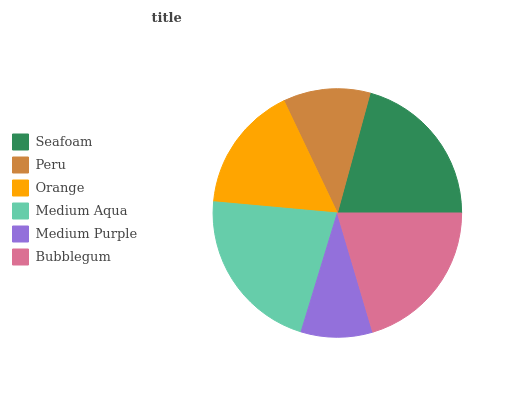Is Medium Purple the minimum?
Answer yes or no. Yes. Is Medium Aqua the maximum?
Answer yes or no. Yes. Is Peru the minimum?
Answer yes or no. No. Is Peru the maximum?
Answer yes or no. No. Is Seafoam greater than Peru?
Answer yes or no. Yes. Is Peru less than Seafoam?
Answer yes or no. Yes. Is Peru greater than Seafoam?
Answer yes or no. No. Is Seafoam less than Peru?
Answer yes or no. No. Is Bubblegum the high median?
Answer yes or no. Yes. Is Orange the low median?
Answer yes or no. Yes. Is Medium Purple the high median?
Answer yes or no. No. Is Medium Purple the low median?
Answer yes or no. No. 